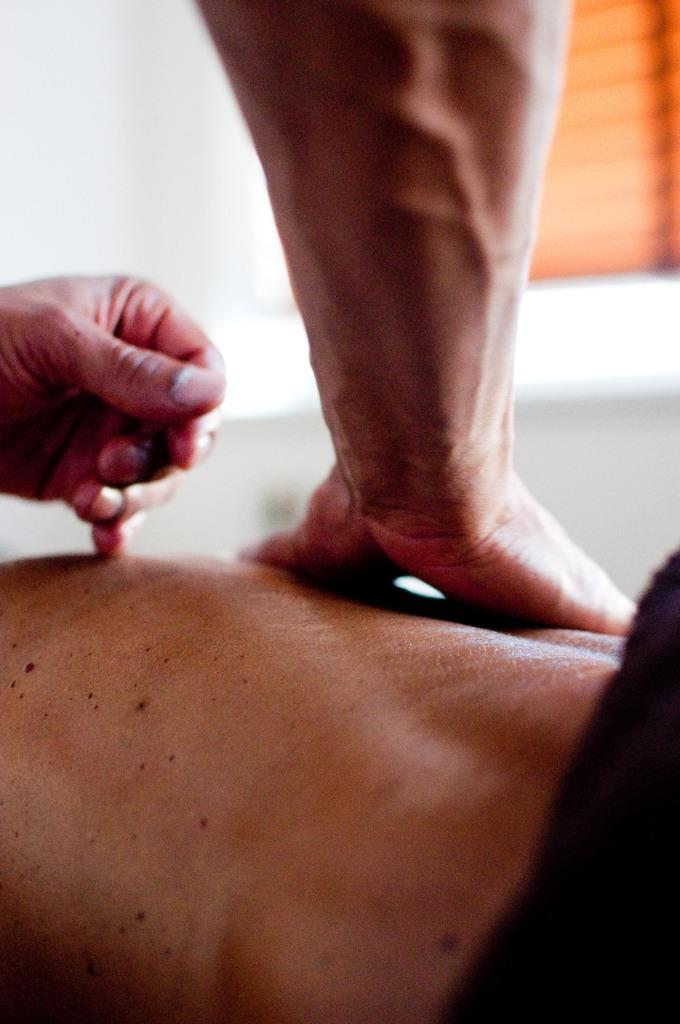What body parts are visible in the image? There are a person's hands visible in the image. What is the person's reaction to the sudden movement of the object in the image? There is no object or movement mentioned in the provided facts, so it is not possible to determine the person's reaction. 